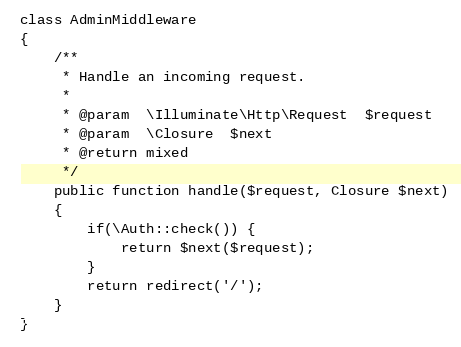Convert code to text. <code><loc_0><loc_0><loc_500><loc_500><_PHP_>
class AdminMiddleware
{
    /**
     * Handle an incoming request.
     *
     * @param  \Illuminate\Http\Request  $request
     * @param  \Closure  $next
     * @return mixed
     */
    public function handle($request, Closure $next)
    {
        if(\Auth::check()) {
            return $next($request);
        }
        return redirect('/');
    }
}
</code> 